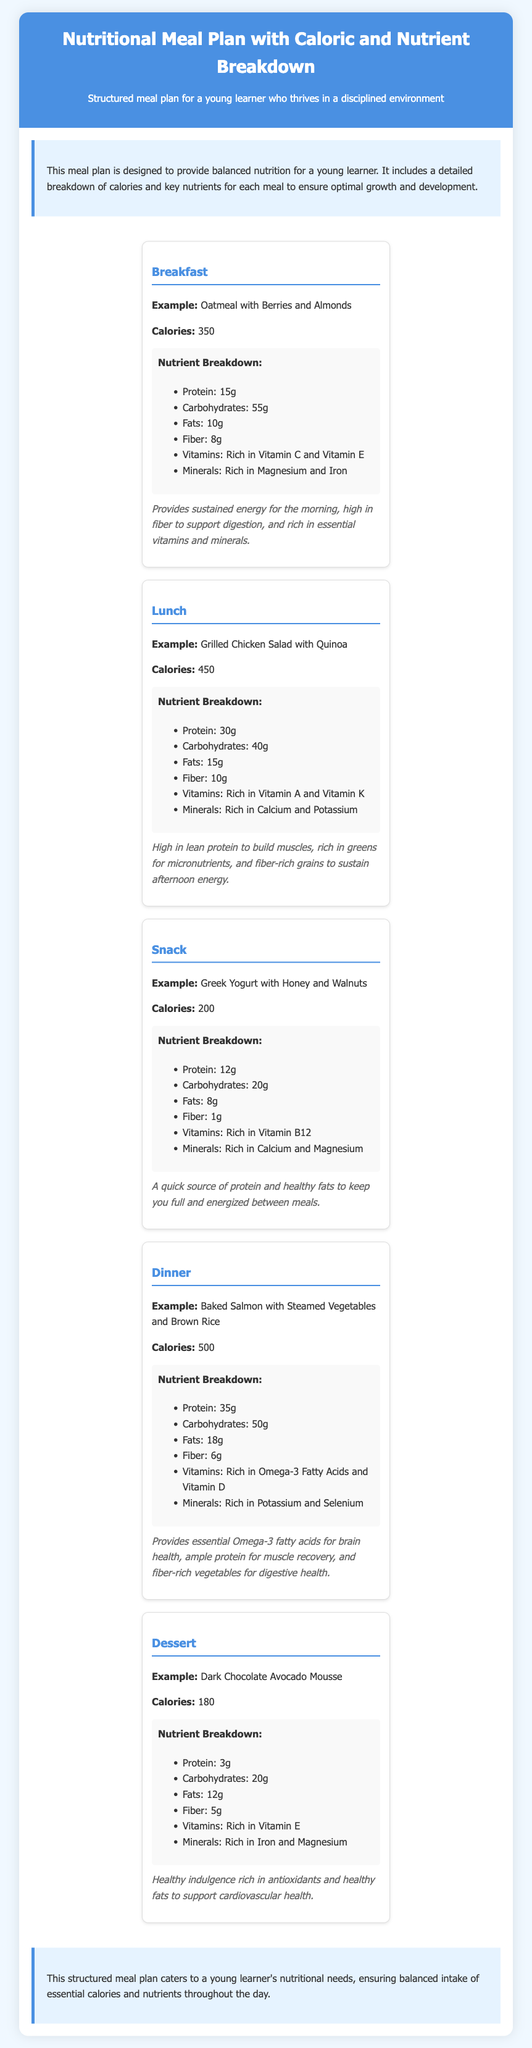What is the calorie count for breakfast? The calorie count for breakfast is specified in the document as 350 calories.
Answer: 350 What dish is suggested for lunch? The document specifies "Grilled Chicken Salad with Quinoa" as the suggested lunch dish.
Answer: Grilled Chicken Salad with Quinoa How many grams of protein are in the dinner meal? The document states that the dinner meal has 35 grams of protein, which is detailed in the meal breakdown.
Answer: 35g Which vitamins are highlighted in the breakfast meal? The breakfast meal lists Vitamin C and Vitamin E as the key vitamins, available in the nutrient breakdown.
Answer: Vitamin C and Vitamin E What is the total caloric value of the meals (excluding dessert)? To get this, we sum the calories from breakfast (350), lunch (450), snack (200), and dinner (500), resulting in a total of 1500 calories.
Answer: 1500 What is the benefit of the snack mentioned in the document? The document mentions the snack provides "a quick source of protein and healthy fats to keep you full and energized."
Answer: Quick source of protein and healthy fats Which meal has the highest calorie count? The highest calorie count is noted for the dinner meal at 500 calories.
Answer: Dinner What type of meal is described last in the document? The last meal described in the document is a dessert, specifically "Dark Chocolate Avocado Mousse."
Answer: Dessert 